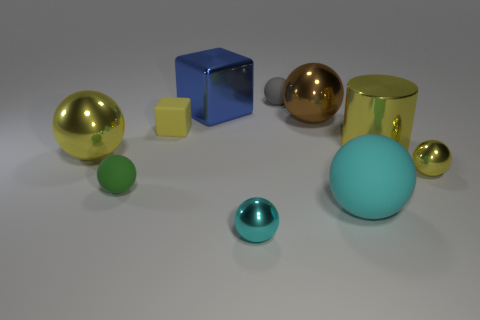Subtract all gray balls. How many balls are left? 6 Subtract all small matte spheres. How many spheres are left? 5 Subtract all brown spheres. Subtract all blue cubes. How many spheres are left? 6 Subtract all blocks. How many objects are left? 8 Subtract all shiny balls. Subtract all small yellow blocks. How many objects are left? 5 Add 3 large shiny balls. How many large shiny balls are left? 5 Add 5 yellow shiny blocks. How many yellow shiny blocks exist? 5 Subtract 0 brown blocks. How many objects are left? 10 